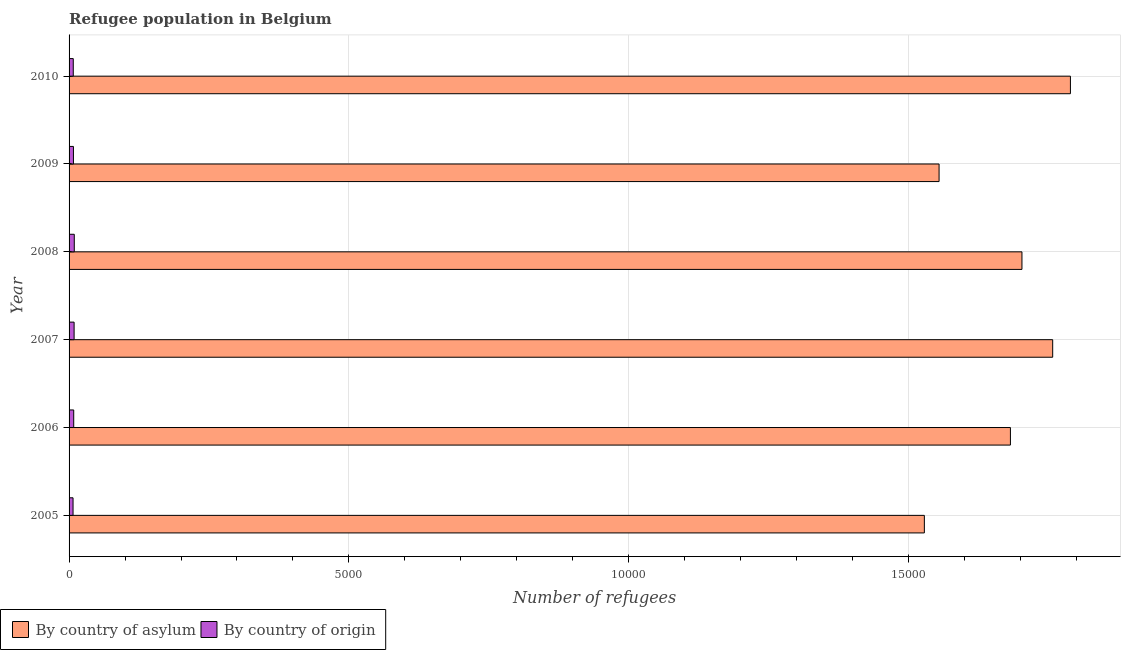How many groups of bars are there?
Keep it short and to the point. 6. Are the number of bars per tick equal to the number of legend labels?
Ensure brevity in your answer.  Yes. Are the number of bars on each tick of the Y-axis equal?
Offer a very short reply. Yes. What is the label of the 4th group of bars from the top?
Ensure brevity in your answer.  2007. In how many cases, is the number of bars for a given year not equal to the number of legend labels?
Your answer should be compact. 0. What is the number of refugees by country of asylum in 2008?
Provide a succinct answer. 1.70e+04. Across all years, what is the maximum number of refugees by country of asylum?
Provide a succinct answer. 1.79e+04. Across all years, what is the minimum number of refugees by country of asylum?
Your response must be concise. 1.53e+04. In which year was the number of refugees by country of origin maximum?
Keep it short and to the point. 2008. What is the total number of refugees by country of asylum in the graph?
Offer a terse response. 1.00e+05. What is the difference between the number of refugees by country of origin in 2005 and that in 2010?
Make the answer very short. -4. What is the difference between the number of refugees by country of asylum in 2006 and the number of refugees by country of origin in 2007?
Ensure brevity in your answer.  1.67e+04. What is the average number of refugees by country of asylum per year?
Provide a succinct answer. 1.67e+04. In the year 2006, what is the difference between the number of refugees by country of asylum and number of refugees by country of origin?
Provide a short and direct response. 1.67e+04. What is the ratio of the number of refugees by country of origin in 2006 to that in 2009?
Offer a very short reply. 1.06. Is the difference between the number of refugees by country of origin in 2009 and 2010 greater than the difference between the number of refugees by country of asylum in 2009 and 2010?
Provide a short and direct response. Yes. What is the difference between the highest and the second highest number of refugees by country of origin?
Offer a terse response. 3. What is the difference between the highest and the lowest number of refugees by country of origin?
Offer a terse response. 22. In how many years, is the number of refugees by country of origin greater than the average number of refugees by country of origin taken over all years?
Give a very brief answer. 3. What does the 1st bar from the top in 2007 represents?
Make the answer very short. By country of origin. What does the 1st bar from the bottom in 2006 represents?
Ensure brevity in your answer.  By country of asylum. How many bars are there?
Provide a short and direct response. 12. How many years are there in the graph?
Keep it short and to the point. 6. What is the difference between two consecutive major ticks on the X-axis?
Your response must be concise. 5000. Does the graph contain any zero values?
Your answer should be compact. No. How many legend labels are there?
Give a very brief answer. 2. What is the title of the graph?
Make the answer very short. Refugee population in Belgium. Does "Private creditors" appear as one of the legend labels in the graph?
Offer a terse response. No. What is the label or title of the X-axis?
Provide a succinct answer. Number of refugees. What is the Number of refugees in By country of asylum in 2005?
Your answer should be very brief. 1.53e+04. What is the Number of refugees of By country of asylum in 2006?
Keep it short and to the point. 1.68e+04. What is the Number of refugees in By country of asylum in 2007?
Provide a short and direct response. 1.76e+04. What is the Number of refugees in By country of asylum in 2008?
Your answer should be compact. 1.70e+04. What is the Number of refugees of By country of origin in 2008?
Your response must be concise. 93. What is the Number of refugees of By country of asylum in 2009?
Make the answer very short. 1.55e+04. What is the Number of refugees of By country of asylum in 2010?
Your answer should be compact. 1.79e+04. Across all years, what is the maximum Number of refugees of By country of asylum?
Your answer should be very brief. 1.79e+04. Across all years, what is the maximum Number of refugees of By country of origin?
Give a very brief answer. 93. Across all years, what is the minimum Number of refugees in By country of asylum?
Ensure brevity in your answer.  1.53e+04. What is the total Number of refugees in By country of asylum in the graph?
Ensure brevity in your answer.  1.00e+05. What is the total Number of refugees of By country of origin in the graph?
Make the answer very short. 490. What is the difference between the Number of refugees in By country of asylum in 2005 and that in 2006?
Make the answer very short. -1538. What is the difference between the Number of refugees of By country of origin in 2005 and that in 2006?
Ensure brevity in your answer.  -12. What is the difference between the Number of refugees in By country of asylum in 2005 and that in 2007?
Your response must be concise. -2293. What is the difference between the Number of refugees of By country of asylum in 2005 and that in 2008?
Ensure brevity in your answer.  -1744. What is the difference between the Number of refugees in By country of asylum in 2005 and that in 2009?
Offer a very short reply. -263. What is the difference between the Number of refugees in By country of asylum in 2005 and that in 2010?
Offer a very short reply. -2610. What is the difference between the Number of refugees of By country of asylum in 2006 and that in 2007?
Offer a very short reply. -755. What is the difference between the Number of refugees in By country of origin in 2006 and that in 2007?
Your response must be concise. -7. What is the difference between the Number of refugees of By country of asylum in 2006 and that in 2008?
Your answer should be compact. -206. What is the difference between the Number of refugees of By country of asylum in 2006 and that in 2009?
Provide a succinct answer. 1275. What is the difference between the Number of refugees of By country of origin in 2006 and that in 2009?
Keep it short and to the point. 5. What is the difference between the Number of refugees of By country of asylum in 2006 and that in 2010?
Ensure brevity in your answer.  -1072. What is the difference between the Number of refugees of By country of asylum in 2007 and that in 2008?
Your answer should be very brief. 549. What is the difference between the Number of refugees in By country of asylum in 2007 and that in 2009?
Your answer should be compact. 2030. What is the difference between the Number of refugees of By country of asylum in 2007 and that in 2010?
Offer a very short reply. -317. What is the difference between the Number of refugees in By country of origin in 2007 and that in 2010?
Ensure brevity in your answer.  15. What is the difference between the Number of refugees of By country of asylum in 2008 and that in 2009?
Ensure brevity in your answer.  1481. What is the difference between the Number of refugees in By country of asylum in 2008 and that in 2010?
Offer a very short reply. -866. What is the difference between the Number of refugees in By country of origin in 2008 and that in 2010?
Provide a short and direct response. 18. What is the difference between the Number of refugees in By country of asylum in 2009 and that in 2010?
Offer a very short reply. -2347. What is the difference between the Number of refugees in By country of origin in 2009 and that in 2010?
Your response must be concise. 3. What is the difference between the Number of refugees of By country of asylum in 2005 and the Number of refugees of By country of origin in 2006?
Offer a very short reply. 1.52e+04. What is the difference between the Number of refugees in By country of asylum in 2005 and the Number of refugees in By country of origin in 2007?
Your answer should be very brief. 1.52e+04. What is the difference between the Number of refugees in By country of asylum in 2005 and the Number of refugees in By country of origin in 2008?
Keep it short and to the point. 1.52e+04. What is the difference between the Number of refugees in By country of asylum in 2005 and the Number of refugees in By country of origin in 2009?
Your response must be concise. 1.52e+04. What is the difference between the Number of refugees of By country of asylum in 2005 and the Number of refugees of By country of origin in 2010?
Your answer should be very brief. 1.52e+04. What is the difference between the Number of refugees of By country of asylum in 2006 and the Number of refugees of By country of origin in 2007?
Make the answer very short. 1.67e+04. What is the difference between the Number of refugees of By country of asylum in 2006 and the Number of refugees of By country of origin in 2008?
Your answer should be compact. 1.67e+04. What is the difference between the Number of refugees in By country of asylum in 2006 and the Number of refugees in By country of origin in 2009?
Ensure brevity in your answer.  1.67e+04. What is the difference between the Number of refugees in By country of asylum in 2006 and the Number of refugees in By country of origin in 2010?
Ensure brevity in your answer.  1.67e+04. What is the difference between the Number of refugees in By country of asylum in 2007 and the Number of refugees in By country of origin in 2008?
Provide a succinct answer. 1.75e+04. What is the difference between the Number of refugees of By country of asylum in 2007 and the Number of refugees of By country of origin in 2009?
Offer a very short reply. 1.75e+04. What is the difference between the Number of refugees in By country of asylum in 2007 and the Number of refugees in By country of origin in 2010?
Offer a terse response. 1.75e+04. What is the difference between the Number of refugees of By country of asylum in 2008 and the Number of refugees of By country of origin in 2009?
Offer a very short reply. 1.69e+04. What is the difference between the Number of refugees in By country of asylum in 2008 and the Number of refugees in By country of origin in 2010?
Offer a terse response. 1.70e+04. What is the difference between the Number of refugees in By country of asylum in 2009 and the Number of refugees in By country of origin in 2010?
Give a very brief answer. 1.55e+04. What is the average Number of refugees of By country of asylum per year?
Your answer should be very brief. 1.67e+04. What is the average Number of refugees of By country of origin per year?
Provide a succinct answer. 81.67. In the year 2005, what is the difference between the Number of refugees in By country of asylum and Number of refugees in By country of origin?
Offer a terse response. 1.52e+04. In the year 2006, what is the difference between the Number of refugees in By country of asylum and Number of refugees in By country of origin?
Give a very brief answer. 1.67e+04. In the year 2007, what is the difference between the Number of refugees in By country of asylum and Number of refugees in By country of origin?
Provide a succinct answer. 1.75e+04. In the year 2008, what is the difference between the Number of refugees of By country of asylum and Number of refugees of By country of origin?
Your response must be concise. 1.69e+04. In the year 2009, what is the difference between the Number of refugees in By country of asylum and Number of refugees in By country of origin?
Provide a short and direct response. 1.55e+04. In the year 2010, what is the difference between the Number of refugees in By country of asylum and Number of refugees in By country of origin?
Your answer should be very brief. 1.78e+04. What is the ratio of the Number of refugees in By country of asylum in 2005 to that in 2006?
Your response must be concise. 0.91. What is the ratio of the Number of refugees in By country of origin in 2005 to that in 2006?
Give a very brief answer. 0.86. What is the ratio of the Number of refugees in By country of asylum in 2005 to that in 2007?
Ensure brevity in your answer.  0.87. What is the ratio of the Number of refugees in By country of origin in 2005 to that in 2007?
Give a very brief answer. 0.79. What is the ratio of the Number of refugees of By country of asylum in 2005 to that in 2008?
Provide a short and direct response. 0.9. What is the ratio of the Number of refugees of By country of origin in 2005 to that in 2008?
Your answer should be compact. 0.76. What is the ratio of the Number of refugees in By country of asylum in 2005 to that in 2009?
Your answer should be very brief. 0.98. What is the ratio of the Number of refugees in By country of origin in 2005 to that in 2009?
Keep it short and to the point. 0.91. What is the ratio of the Number of refugees of By country of asylum in 2005 to that in 2010?
Your answer should be very brief. 0.85. What is the ratio of the Number of refugees of By country of origin in 2005 to that in 2010?
Your answer should be compact. 0.95. What is the ratio of the Number of refugees in By country of asylum in 2006 to that in 2007?
Provide a short and direct response. 0.96. What is the ratio of the Number of refugees of By country of origin in 2006 to that in 2007?
Provide a succinct answer. 0.92. What is the ratio of the Number of refugees in By country of asylum in 2006 to that in 2008?
Ensure brevity in your answer.  0.99. What is the ratio of the Number of refugees of By country of origin in 2006 to that in 2008?
Ensure brevity in your answer.  0.89. What is the ratio of the Number of refugees of By country of asylum in 2006 to that in 2009?
Offer a terse response. 1.08. What is the ratio of the Number of refugees of By country of origin in 2006 to that in 2009?
Your answer should be compact. 1.06. What is the ratio of the Number of refugees in By country of asylum in 2006 to that in 2010?
Ensure brevity in your answer.  0.94. What is the ratio of the Number of refugees in By country of origin in 2006 to that in 2010?
Make the answer very short. 1.11. What is the ratio of the Number of refugees of By country of asylum in 2007 to that in 2008?
Your answer should be very brief. 1.03. What is the ratio of the Number of refugees of By country of origin in 2007 to that in 2008?
Your response must be concise. 0.97. What is the ratio of the Number of refugees in By country of asylum in 2007 to that in 2009?
Make the answer very short. 1.13. What is the ratio of the Number of refugees of By country of origin in 2007 to that in 2009?
Your answer should be compact. 1.15. What is the ratio of the Number of refugees in By country of asylum in 2007 to that in 2010?
Your response must be concise. 0.98. What is the ratio of the Number of refugees in By country of asylum in 2008 to that in 2009?
Provide a succinct answer. 1.1. What is the ratio of the Number of refugees in By country of origin in 2008 to that in 2009?
Offer a terse response. 1.19. What is the ratio of the Number of refugees of By country of asylum in 2008 to that in 2010?
Keep it short and to the point. 0.95. What is the ratio of the Number of refugees of By country of origin in 2008 to that in 2010?
Offer a terse response. 1.24. What is the ratio of the Number of refugees of By country of asylum in 2009 to that in 2010?
Ensure brevity in your answer.  0.87. What is the difference between the highest and the second highest Number of refugees in By country of asylum?
Ensure brevity in your answer.  317. What is the difference between the highest and the second highest Number of refugees of By country of origin?
Your answer should be very brief. 3. What is the difference between the highest and the lowest Number of refugees in By country of asylum?
Provide a succinct answer. 2610. What is the difference between the highest and the lowest Number of refugees of By country of origin?
Make the answer very short. 22. 